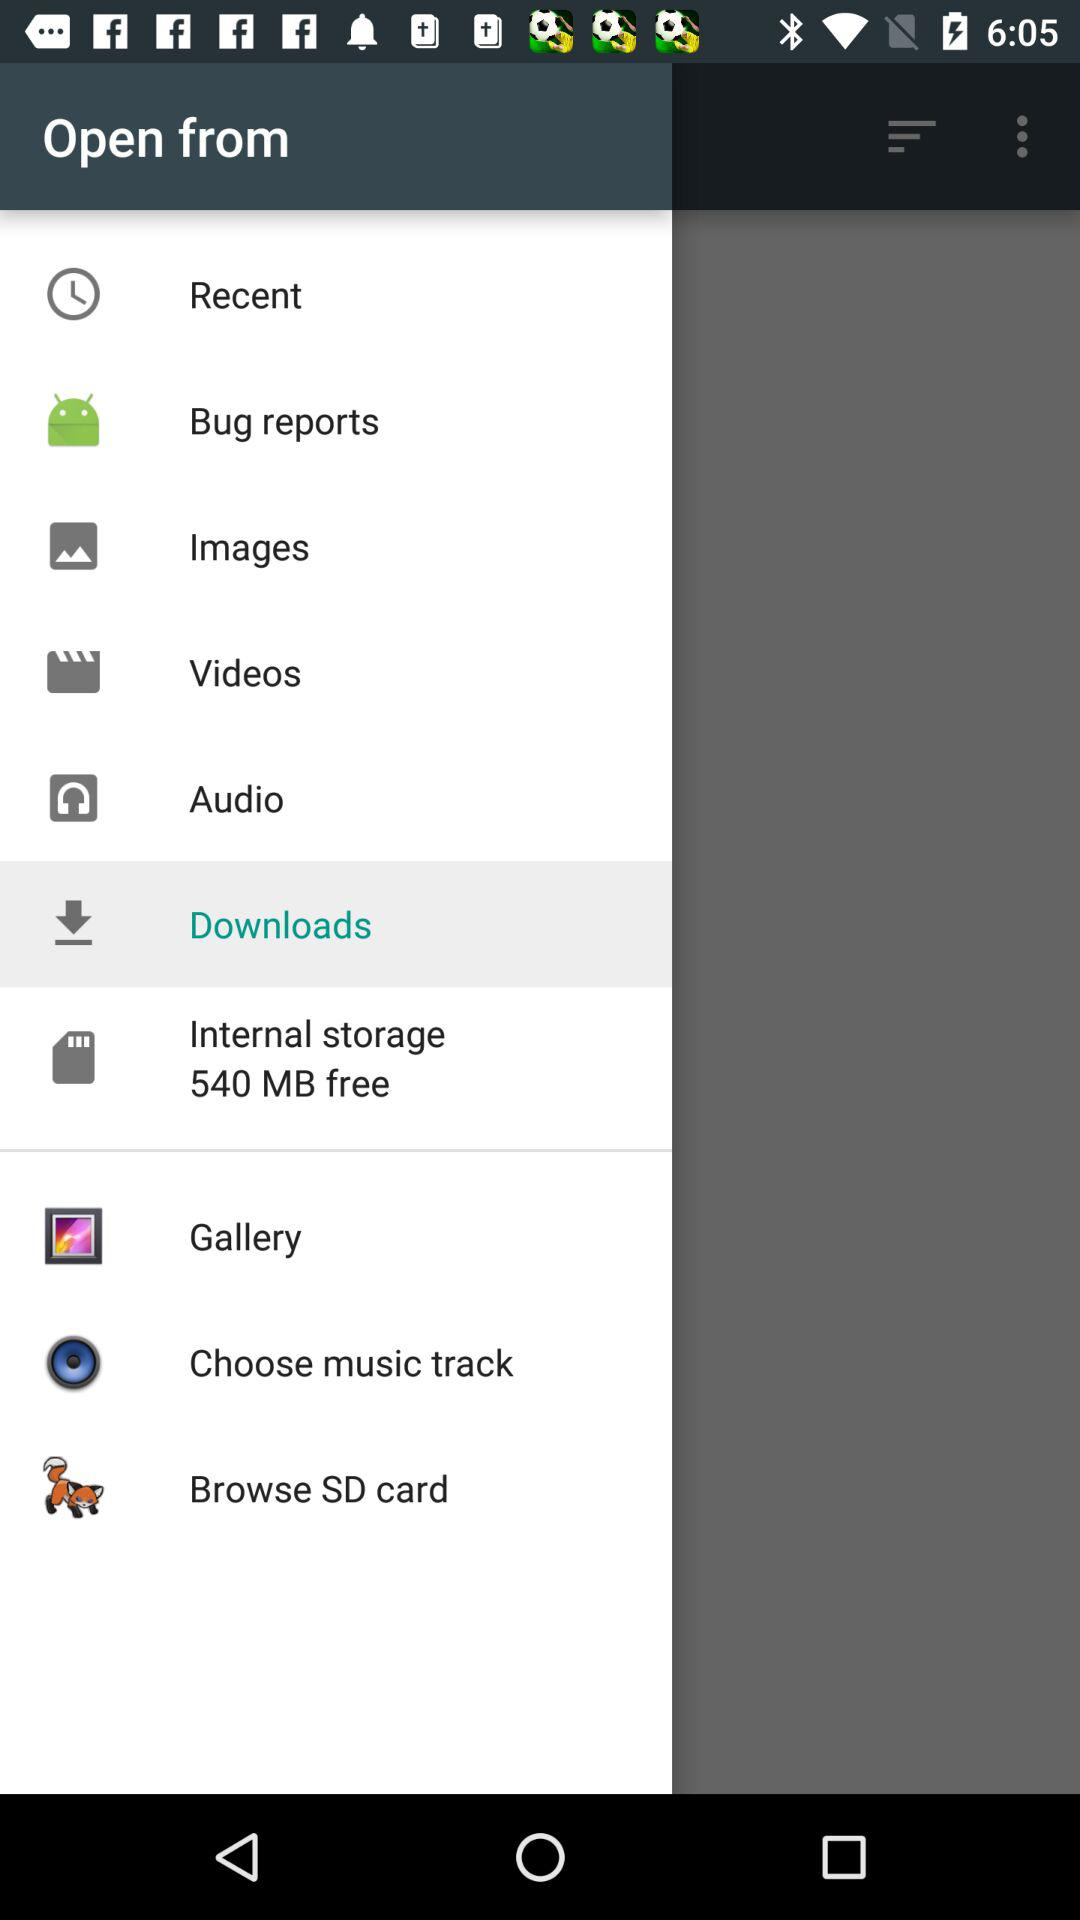How much internal storage is free? There is 540 MB of free internal storage. 